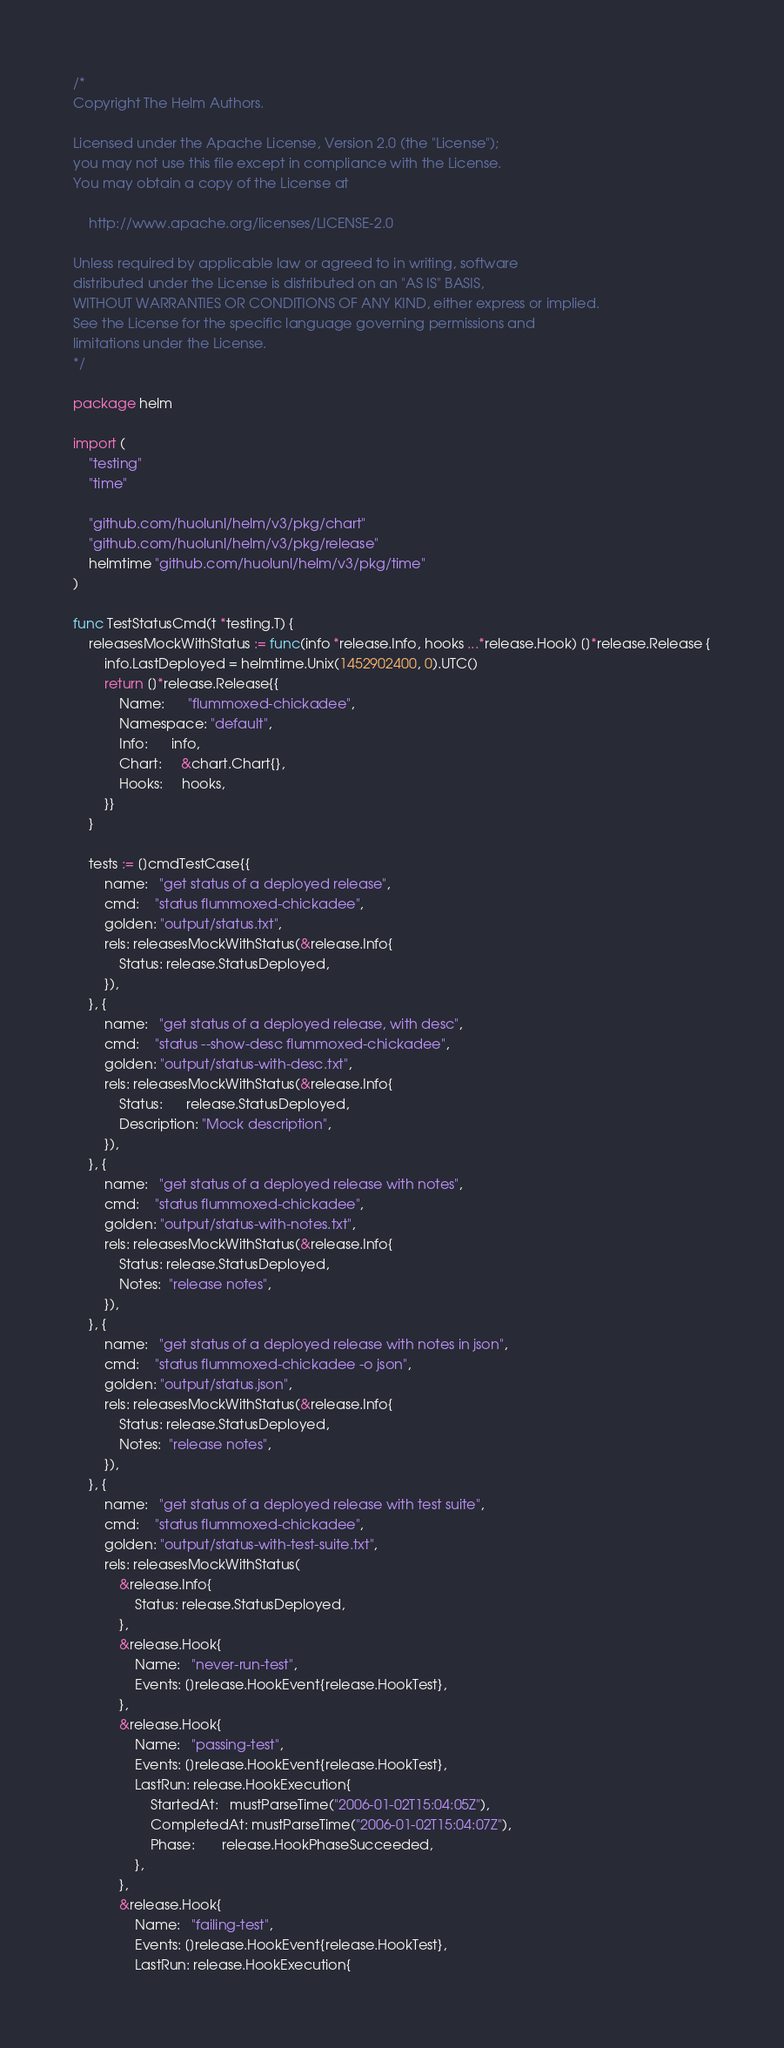Convert code to text. <code><loc_0><loc_0><loc_500><loc_500><_Go_>/*
Copyright The Helm Authors.

Licensed under the Apache License, Version 2.0 (the "License");
you may not use this file except in compliance with the License.
You may obtain a copy of the License at

    http://www.apache.org/licenses/LICENSE-2.0

Unless required by applicable law or agreed to in writing, software
distributed under the License is distributed on an "AS IS" BASIS,
WITHOUT WARRANTIES OR CONDITIONS OF ANY KIND, either express or implied.
See the License for the specific language governing permissions and
limitations under the License.
*/

package helm

import (
	"testing"
	"time"

	"github.com/huolunl/helm/v3/pkg/chart"
	"github.com/huolunl/helm/v3/pkg/release"
	helmtime "github.com/huolunl/helm/v3/pkg/time"
)

func TestStatusCmd(t *testing.T) {
	releasesMockWithStatus := func(info *release.Info, hooks ...*release.Hook) []*release.Release {
		info.LastDeployed = helmtime.Unix(1452902400, 0).UTC()
		return []*release.Release{{
			Name:      "flummoxed-chickadee",
			Namespace: "default",
			Info:      info,
			Chart:     &chart.Chart{},
			Hooks:     hooks,
		}}
	}

	tests := []cmdTestCase{{
		name:   "get status of a deployed release",
		cmd:    "status flummoxed-chickadee",
		golden: "output/status.txt",
		rels: releasesMockWithStatus(&release.Info{
			Status: release.StatusDeployed,
		}),
	}, {
		name:   "get status of a deployed release, with desc",
		cmd:    "status --show-desc flummoxed-chickadee",
		golden: "output/status-with-desc.txt",
		rels: releasesMockWithStatus(&release.Info{
			Status:      release.StatusDeployed,
			Description: "Mock description",
		}),
	}, {
		name:   "get status of a deployed release with notes",
		cmd:    "status flummoxed-chickadee",
		golden: "output/status-with-notes.txt",
		rels: releasesMockWithStatus(&release.Info{
			Status: release.StatusDeployed,
			Notes:  "release notes",
		}),
	}, {
		name:   "get status of a deployed release with notes in json",
		cmd:    "status flummoxed-chickadee -o json",
		golden: "output/status.json",
		rels: releasesMockWithStatus(&release.Info{
			Status: release.StatusDeployed,
			Notes:  "release notes",
		}),
	}, {
		name:   "get status of a deployed release with test suite",
		cmd:    "status flummoxed-chickadee",
		golden: "output/status-with-test-suite.txt",
		rels: releasesMockWithStatus(
			&release.Info{
				Status: release.StatusDeployed,
			},
			&release.Hook{
				Name:   "never-run-test",
				Events: []release.HookEvent{release.HookTest},
			},
			&release.Hook{
				Name:   "passing-test",
				Events: []release.HookEvent{release.HookTest},
				LastRun: release.HookExecution{
					StartedAt:   mustParseTime("2006-01-02T15:04:05Z"),
					CompletedAt: mustParseTime("2006-01-02T15:04:07Z"),
					Phase:       release.HookPhaseSucceeded,
				},
			},
			&release.Hook{
				Name:   "failing-test",
				Events: []release.HookEvent{release.HookTest},
				LastRun: release.HookExecution{</code> 